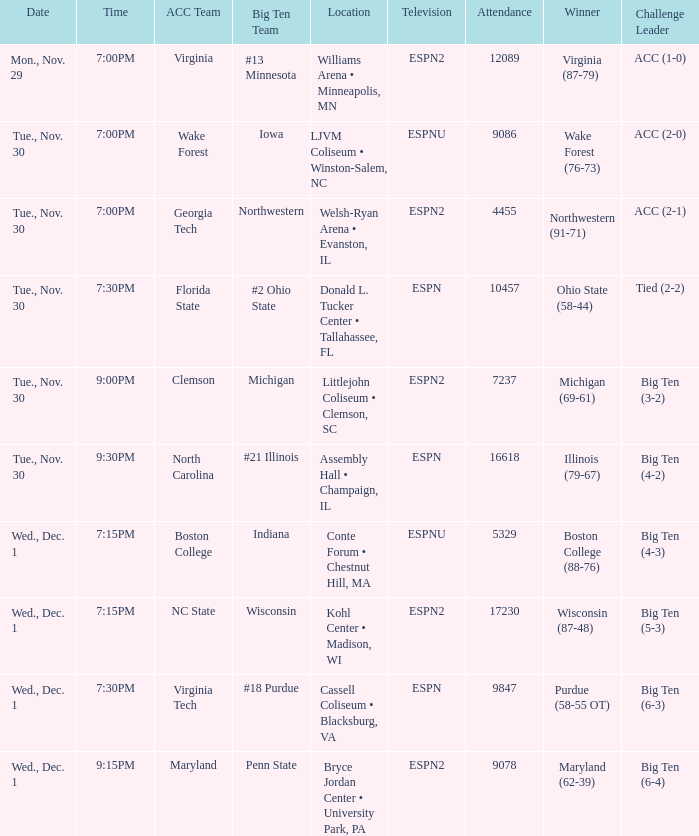Who were the competition heads of the games triumphed by boston college (88-76)? Big Ten (4-3). 